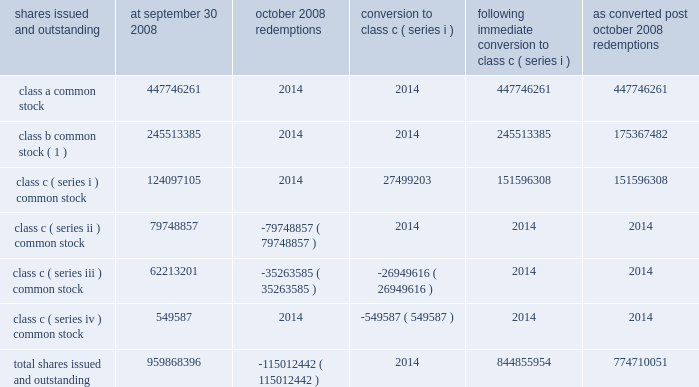Visa inc .
Notes to consolidated financial statements 2014 ( continued ) september 30 , 2008 ( in millions , except as noted ) require the company to redeem all class c ( series ii ) common stock at any time after december 4 , 2008 .
Therefore , in march 2008 , the company reclassified all class c ( series ii ) common stock at its then fair value of $ 1.125 billion to temporary equity on the company 2019s consolidated balance sheet with a corresponding reduction in additional paid-in-capital of $ 1.104 billion and accumulated income ( deficit ) of $ 21 million .
The company accreted this stock to its redemption price of $ 1.146 billion , adjusted for dividends and certain other adjustments , on a straight-line basis , from march 2008 to october 2008 through accumulated income .
See note 4 2014visa europe for a roll-forward of the balance of class c ( series ii ) common stock .
The table sets forth the number of shares of common stock issued and outstanding by class at september 30 , 2008 and the impact of the october 2008 redemptions and subsequent conversion of the remaining outstanding shares of class c ( series iii and series iv ) to class c ( series i ) shares and the number of shares of common stock issued and outstanding after the october 2008 redemptions in total and on as converted basis : shares issued and outstanding september 30 , october 2008 redemptions conversion to class c ( series i ) following immediate conversion to class c ( series i ) converted post october redemptions .
( 1 ) all voting and dividend payment rights are based on the number of shares held multiplied by the applicable conversion rate in effect on the record date , as discussed below .
Subsequent to the ipo and as a result of the initial funding of the litigation escrow account , the conversion rate applicable to class b common stock was approximately 0.71 shares of class a common stock for each share of class b common stock .
Special ipo cash and stock dividends received from cost method investees , net of tax several of the company 2019s cost method investees are also holders of class c ( series i ) common stock and therefore participated in the initial share redemption in march 2008 .
Certain of these investees elected to declare a special cash dividend to return to their owners on a pro rata basis , the proceeds received as a result of the redemption of a portion of their class c ( series i ) common stock .
The dividends represent the return of redemption proceeds .
As a result of the company 2019s ownership interest in these cost method investees , the company received approximately $ 21 million of special dividends from these investees during the third fiscal quarter and recorded a receivable of $ 8 million in prepaid and other assets on its consolidated balance sheet at september 30 , 2008 for a dividend declared by these investees during the fourth fiscal quarter .
In addition , another investee elected to distribute its entire ownership in the company 2019s class c ( series i ) common stock through the distribution of these shares to its investors on a pro rata basis .
As a result , the company received 525443 shares of its own class c ( series i ) common stock during the fourth fiscal quarter and recorded $ 35 million in treasury stock .
The value of the treasury stock was calculated based on sales prices of other recent class c ( series i ) stock transactions by other class c .
What portion of the total shares issued and outstanding are class a common stock? 
Computations: (447746261 / 959868396)
Answer: 0.46647. 